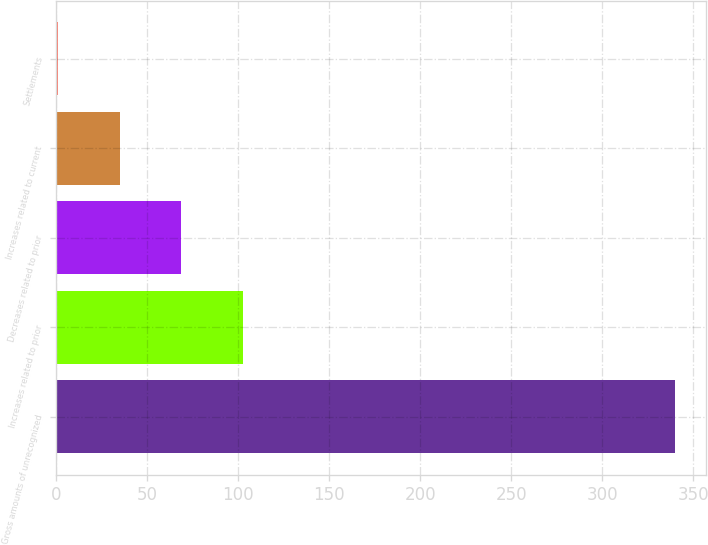Convert chart to OTSL. <chart><loc_0><loc_0><loc_500><loc_500><bar_chart><fcel>Gross amounts of unrecognized<fcel>Increases related to prior<fcel>Decreases related to prior<fcel>Increases related to current<fcel>Settlements<nl><fcel>340<fcel>102.7<fcel>68.8<fcel>34.9<fcel>1<nl></chart> 